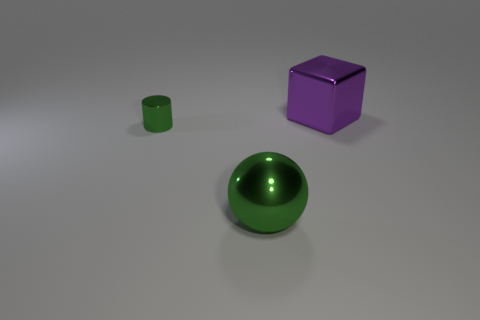There is a thing that is the same color as the tiny cylinder; what is it made of?
Provide a succinct answer. Metal. What number of other small metal cylinders are the same color as the tiny shiny cylinder?
Give a very brief answer. 0. There is a big object that is in front of the small green metallic cylinder; is its shape the same as the small green thing?
Offer a very short reply. No. Is the number of green metallic cylinders that are right of the tiny green shiny object less than the number of cylinders that are in front of the big metallic cube?
Your answer should be compact. Yes. There is a big object that is in front of the purple cube; what material is it?
Your response must be concise. Metal. There is a cylinder that is the same color as the ball; what size is it?
Offer a terse response. Small. Is there a purple matte sphere that has the same size as the shiny ball?
Your answer should be very brief. No. There is a purple thing; does it have the same shape as the green shiny thing in front of the small shiny object?
Keep it short and to the point. No. Do the green thing that is in front of the cylinder and the metallic thing that is behind the green cylinder have the same size?
Give a very brief answer. Yes. What number of other things are there of the same shape as the big purple object?
Give a very brief answer. 0. 